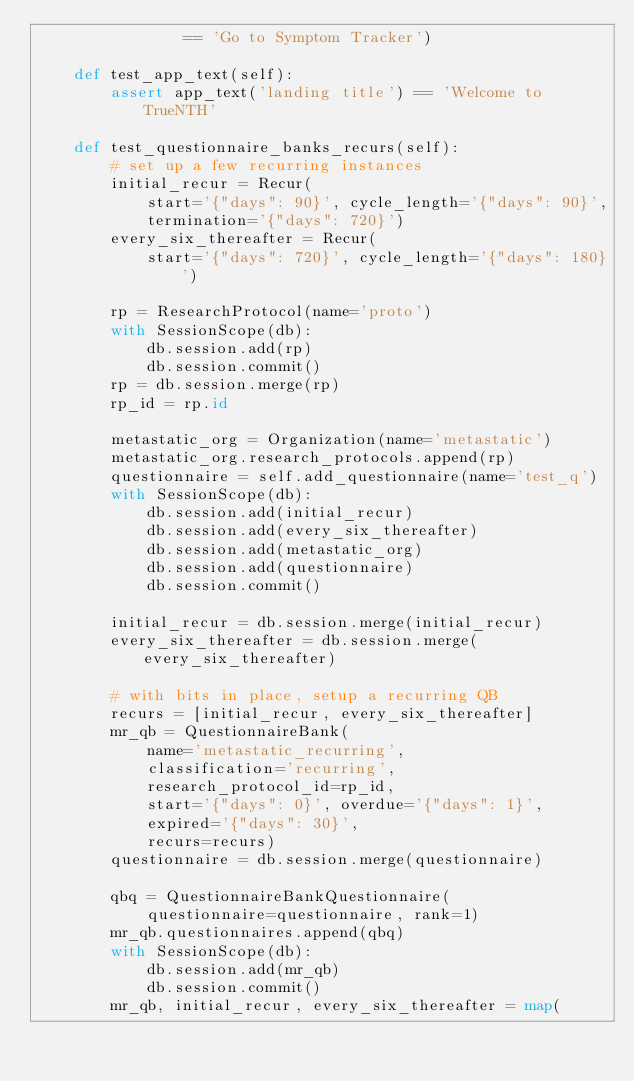<code> <loc_0><loc_0><loc_500><loc_500><_Python_>                == 'Go to Symptom Tracker')

    def test_app_text(self):
        assert app_text('landing title') == 'Welcome to TrueNTH'

    def test_questionnaire_banks_recurs(self):
        # set up a few recurring instances
        initial_recur = Recur(
            start='{"days": 90}', cycle_length='{"days": 90}',
            termination='{"days": 720}')
        every_six_thereafter = Recur(
            start='{"days": 720}', cycle_length='{"days": 180}')

        rp = ResearchProtocol(name='proto')
        with SessionScope(db):
            db.session.add(rp)
            db.session.commit()
        rp = db.session.merge(rp)
        rp_id = rp.id

        metastatic_org = Organization(name='metastatic')
        metastatic_org.research_protocols.append(rp)
        questionnaire = self.add_questionnaire(name='test_q')
        with SessionScope(db):
            db.session.add(initial_recur)
            db.session.add(every_six_thereafter)
            db.session.add(metastatic_org)
            db.session.add(questionnaire)
            db.session.commit()

        initial_recur = db.session.merge(initial_recur)
        every_six_thereafter = db.session.merge(every_six_thereafter)

        # with bits in place, setup a recurring QB
        recurs = [initial_recur, every_six_thereafter]
        mr_qb = QuestionnaireBank(
            name='metastatic_recurring',
            classification='recurring',
            research_protocol_id=rp_id,
            start='{"days": 0}', overdue='{"days": 1}',
            expired='{"days": 30}',
            recurs=recurs)
        questionnaire = db.session.merge(questionnaire)

        qbq = QuestionnaireBankQuestionnaire(
            questionnaire=questionnaire, rank=1)
        mr_qb.questionnaires.append(qbq)
        with SessionScope(db):
            db.session.add(mr_qb)
            db.session.commit()
        mr_qb, initial_recur, every_six_thereafter = map(</code> 